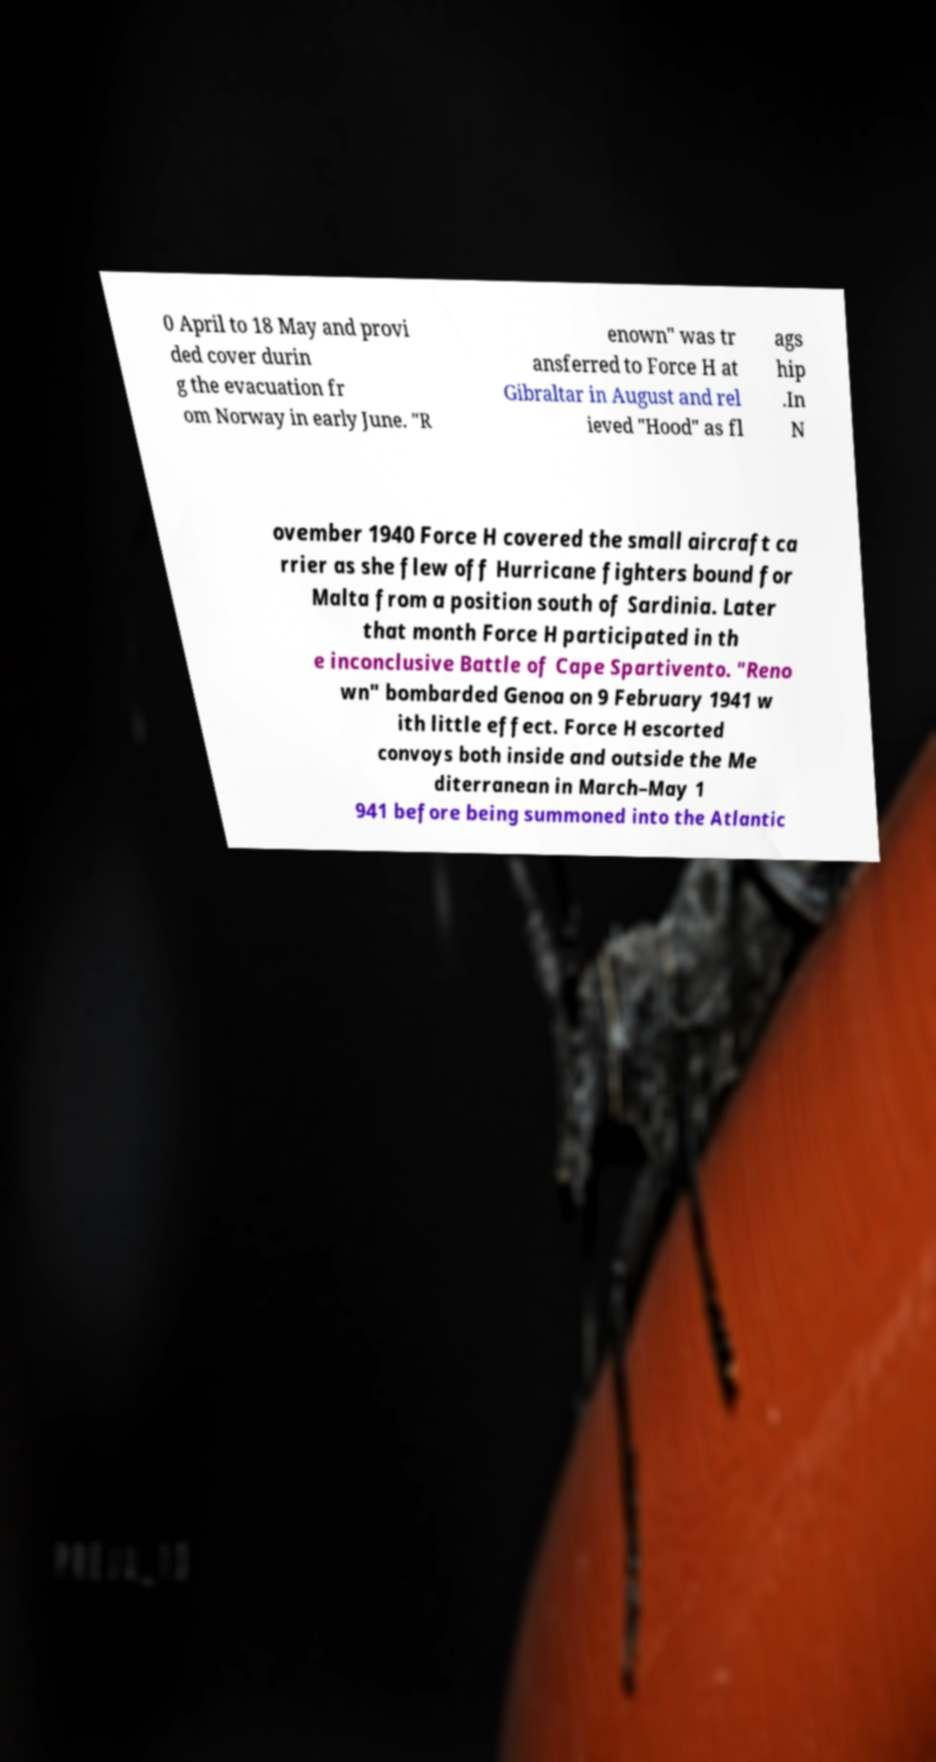Could you assist in decoding the text presented in this image and type it out clearly? 0 April to 18 May and provi ded cover durin g the evacuation fr om Norway in early June. "R enown" was tr ansferred to Force H at Gibraltar in August and rel ieved "Hood" as fl ags hip .In N ovember 1940 Force H covered the small aircraft ca rrier as she flew off Hurricane fighters bound for Malta from a position south of Sardinia. Later that month Force H participated in th e inconclusive Battle of Cape Spartivento. "Reno wn" bombarded Genoa on 9 February 1941 w ith little effect. Force H escorted convoys both inside and outside the Me diterranean in March–May 1 941 before being summoned into the Atlantic 